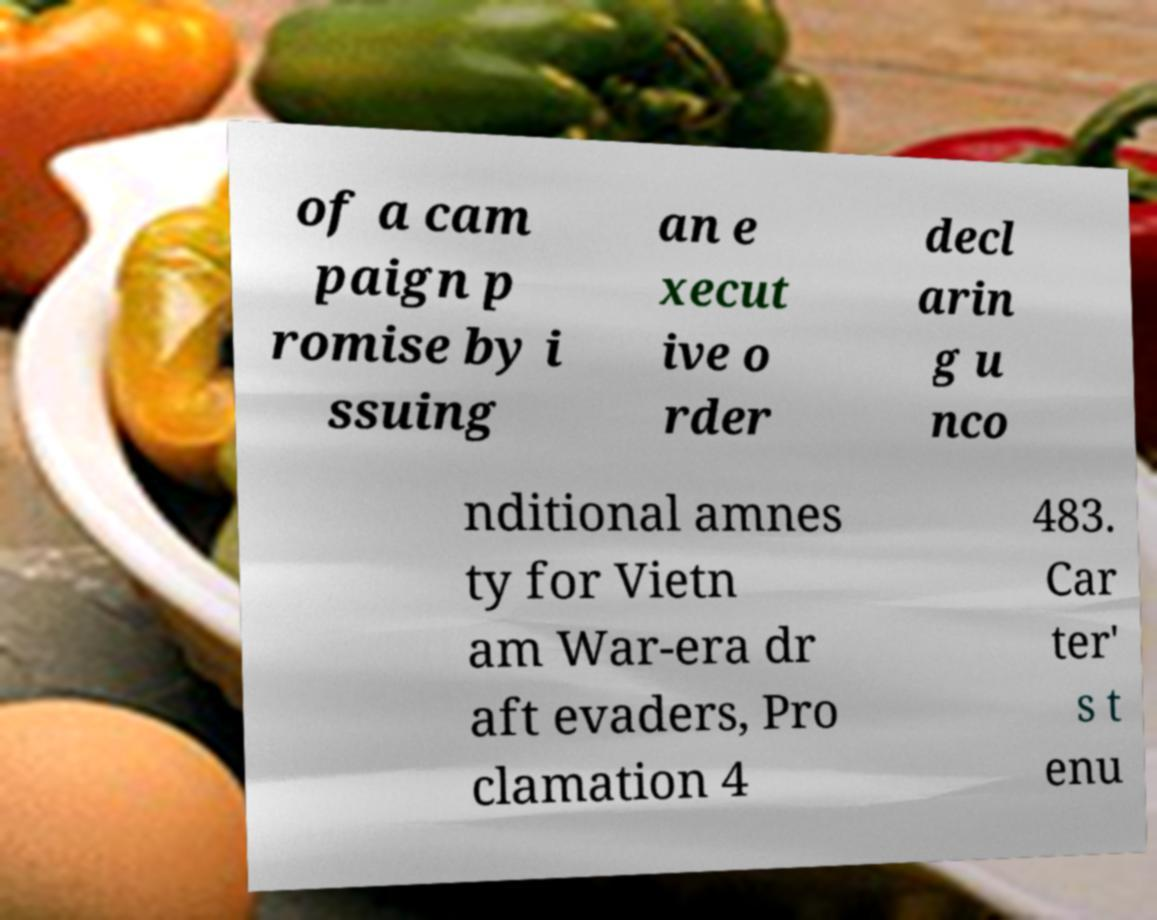Can you read and provide the text displayed in the image?This photo seems to have some interesting text. Can you extract and type it out for me? of a cam paign p romise by i ssuing an e xecut ive o rder decl arin g u nco nditional amnes ty for Vietn am War-era dr aft evaders, Pro clamation 4 483. Car ter' s t enu 